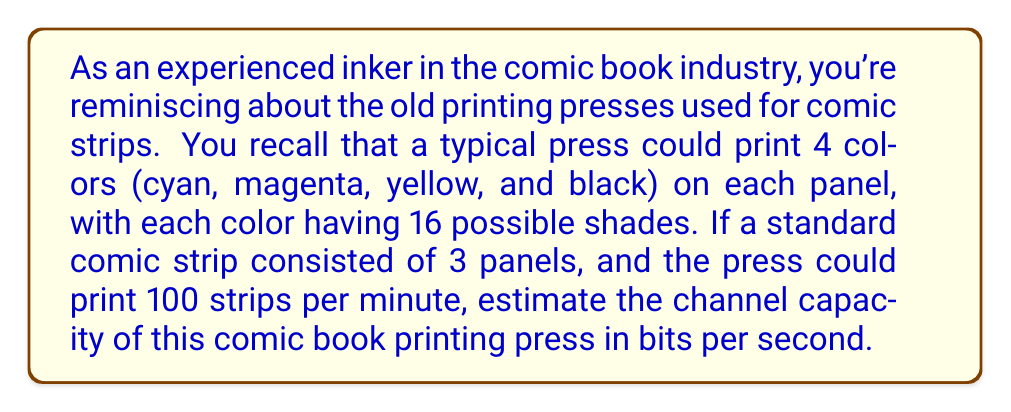Provide a solution to this math problem. Let's approach this step-by-step:

1) First, we need to calculate the information content of a single panel:
   - Each panel uses 4 colors
   - Each color has 16 possible shades
   - The number of possible combinations for one panel is $16^4 = 65,536$
   - The information content of one panel is $\log_2(65,536) = 16$ bits

2) Now, let's calculate the information content of a full comic strip:
   - Each strip has 3 panels
   - Information content of a strip = $3 * 16 = 48$ bits

3) The press prints 100 strips per minute:
   - Information per minute = $100 * 48 = 4,800$ bits

4) To convert this to bits per second:
   - Bits per second = $4,800 / 60 = 80$ bits/second

Therefore, the channel capacity of the comic book printing press is approximately 80 bits per second.

Note: This calculation assumes that every possible combination of colors and shades is equally likely and that there's no compression or redundancy in the printing process. In reality, certain color combinations might be more common than others, which could affect the actual information content.
Answer: The estimated channel capacity of the comic book printing press is 80 bits per second. 